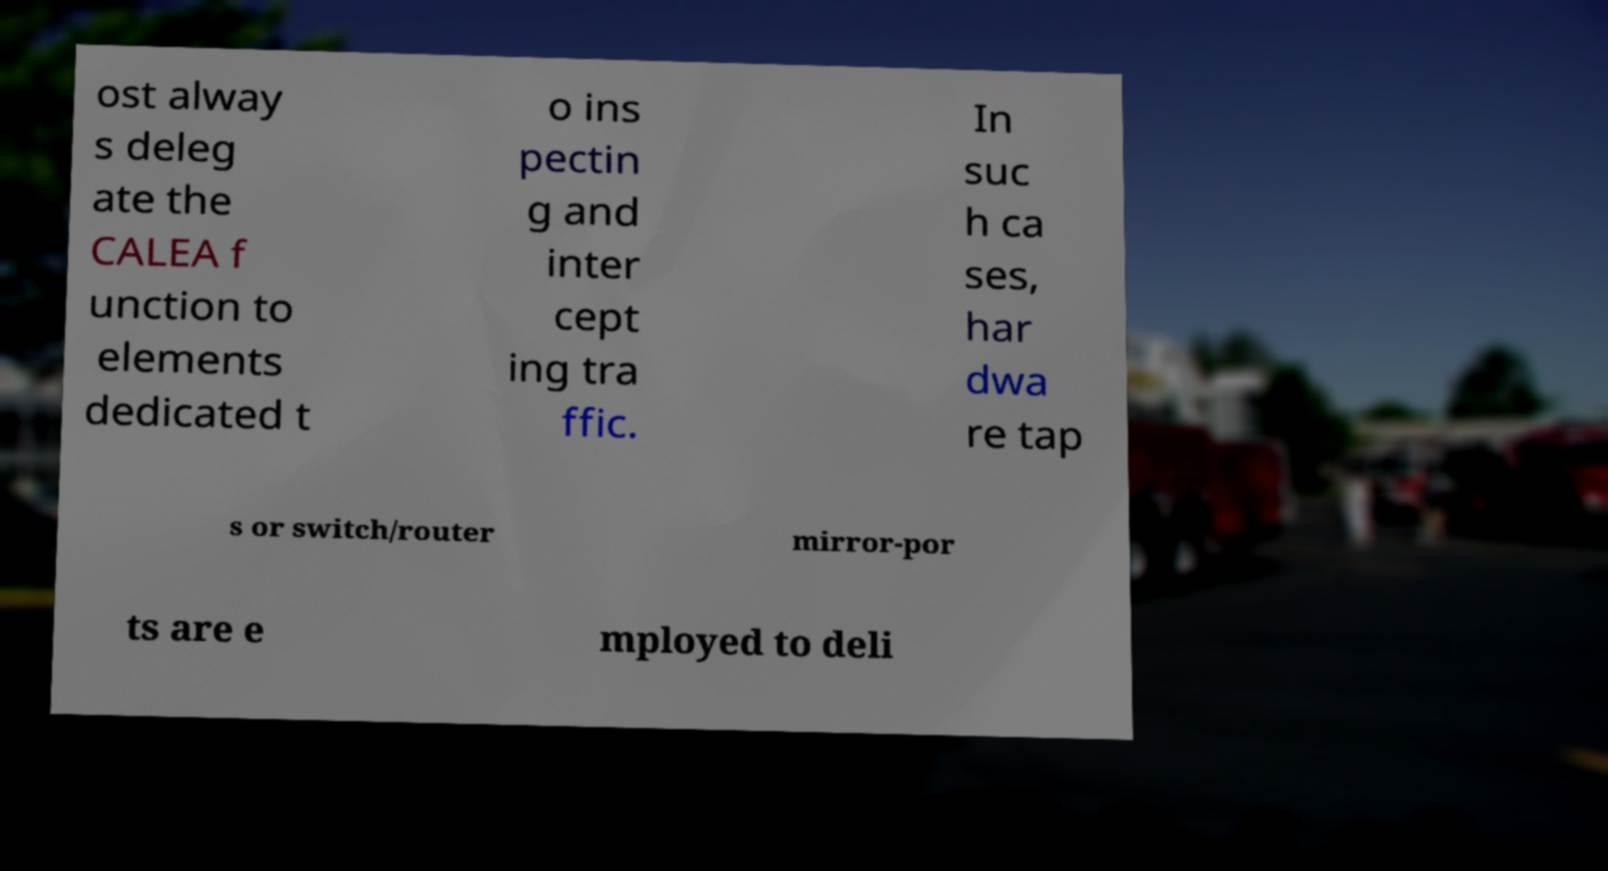What messages or text are displayed in this image? I need them in a readable, typed format. ost alway s deleg ate the CALEA f unction to elements dedicated t o ins pectin g and inter cept ing tra ffic. In suc h ca ses, har dwa re tap s or switch/router mirror-por ts are e mployed to deli 